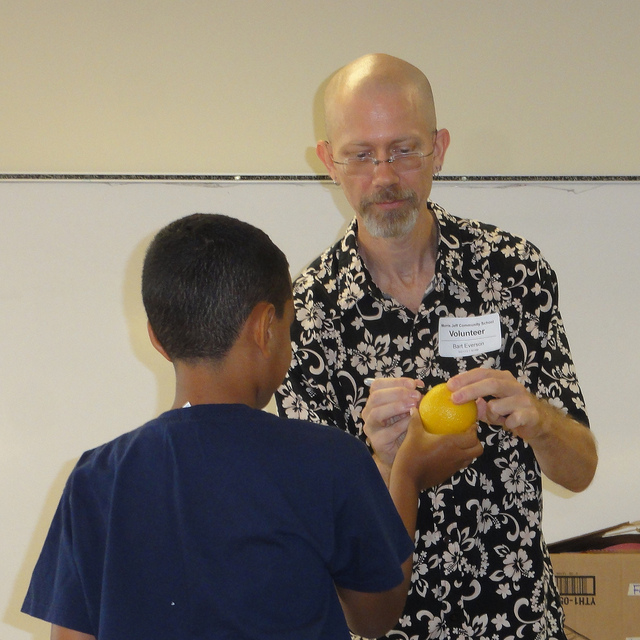Identify the text contained in this image. Volunteer F LHTY 